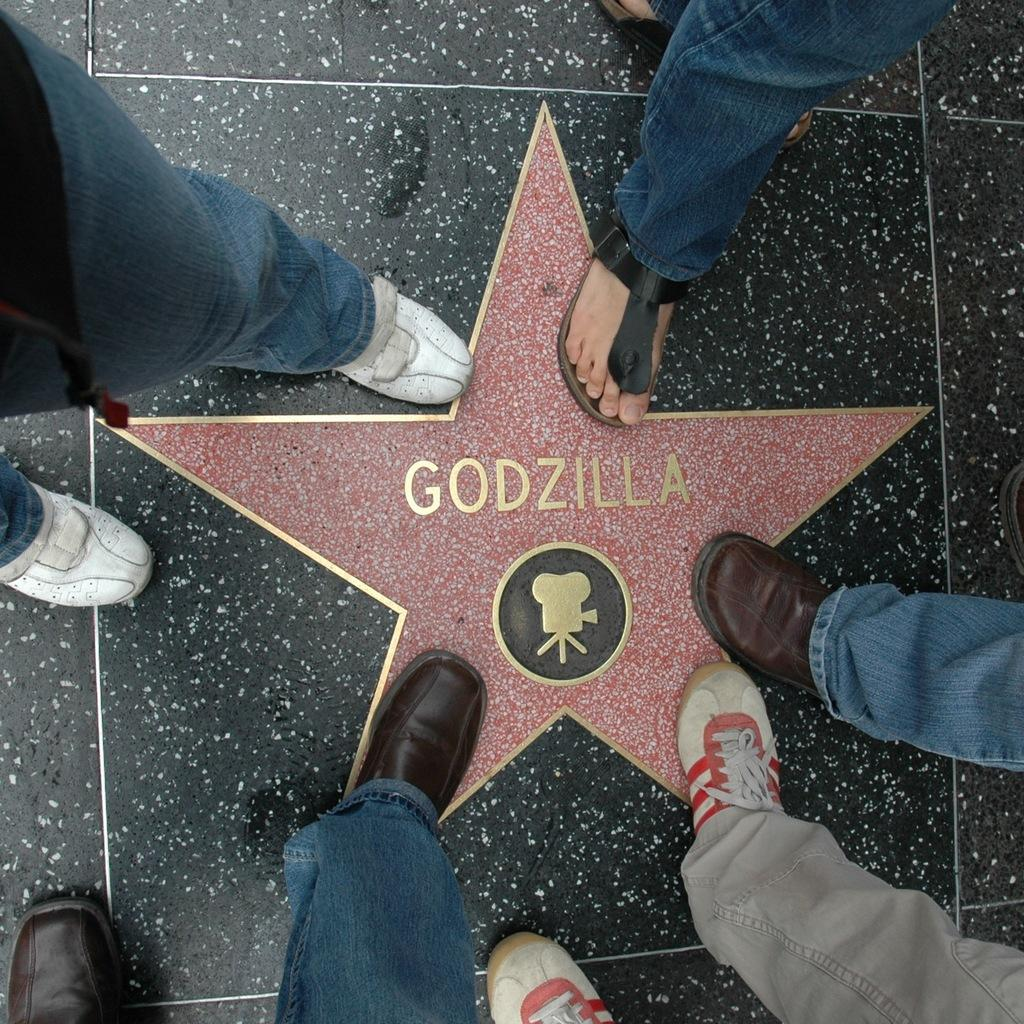What can be seen at the bottom of the image? There are feet of a few people in the image. What are the feet placed on? The feet are placed on a surface. Is there any branding or identification on the surface? Yes, there is a logo on the surface. What type of seafood is being served for lunch in the image? There is no seafood or lunch depicted in the image; it only shows feet placed on a surface with a logo. 